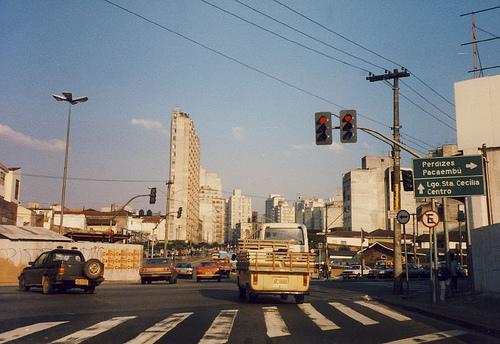What city is this?
Short answer required. Mexico city. How many white lines are there?
Short answer required. 9. Is there a bus stop nearby?
Concise answer only. No. Which way do I turn to go to Perdizes?
Be succinct. Right. What letter on a sign has a line through it?
Short answer required. E. 